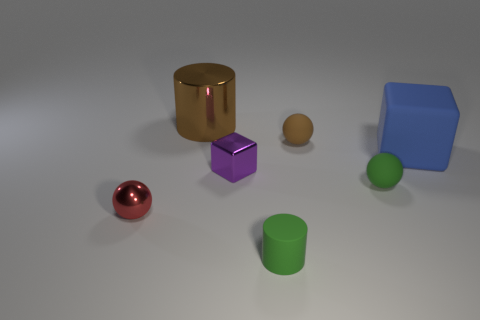Are there any other things that are the same material as the green cylinder?
Provide a short and direct response. Yes. Is there a brown rubber object of the same size as the blue object?
Your answer should be very brief. No. There is a red sphere that is the same size as the rubber cylinder; what is it made of?
Your answer should be compact. Metal. There is a metal object behind the big rubber thing; is it the same size as the cylinder in front of the large brown cylinder?
Keep it short and to the point. No. How many things are blocks or small balls that are on the right side of the red metallic thing?
Your answer should be very brief. 4. Is there another red object of the same shape as the tiny red metal object?
Ensure brevity in your answer.  No. There is a rubber object that is behind the large thing that is on the right side of the metal cylinder; how big is it?
Give a very brief answer. Small. Is the tiny shiny block the same color as the matte cylinder?
Your response must be concise. No. How many metal things are either big red cylinders or blocks?
Offer a terse response. 1. What number of brown cylinders are there?
Offer a very short reply. 1. 